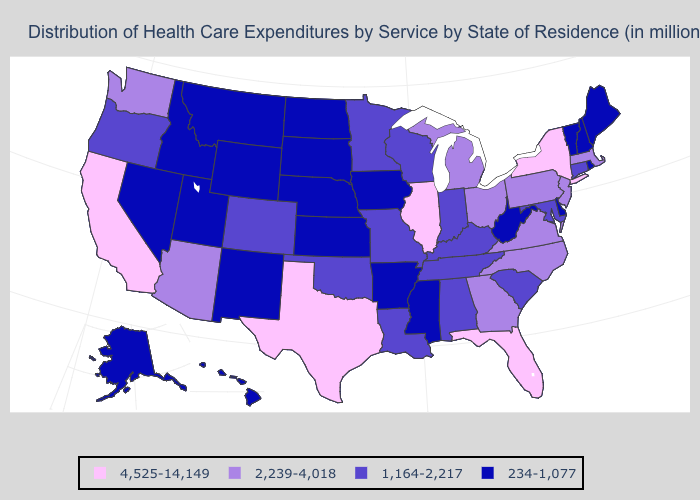Name the states that have a value in the range 234-1,077?
Concise answer only. Alaska, Arkansas, Delaware, Hawaii, Idaho, Iowa, Kansas, Maine, Mississippi, Montana, Nebraska, Nevada, New Hampshire, New Mexico, North Dakota, Rhode Island, South Dakota, Utah, Vermont, West Virginia, Wyoming. Which states have the highest value in the USA?
Write a very short answer. California, Florida, Illinois, New York, Texas. What is the value of Hawaii?
Be succinct. 234-1,077. What is the value of Nebraska?
Write a very short answer. 234-1,077. What is the lowest value in states that border Colorado?
Concise answer only. 234-1,077. Does Minnesota have the lowest value in the USA?
Keep it brief. No. What is the value of New Hampshire?
Keep it brief. 234-1,077. How many symbols are there in the legend?
Keep it brief. 4. What is the highest value in states that border Michigan?
Keep it brief. 2,239-4,018. Name the states that have a value in the range 1,164-2,217?
Answer briefly. Alabama, Colorado, Connecticut, Indiana, Kentucky, Louisiana, Maryland, Minnesota, Missouri, Oklahoma, Oregon, South Carolina, Tennessee, Wisconsin. Among the states that border Alabama , which have the highest value?
Concise answer only. Florida. Which states have the lowest value in the West?
Quick response, please. Alaska, Hawaii, Idaho, Montana, Nevada, New Mexico, Utah, Wyoming. What is the lowest value in the USA?
Be succinct. 234-1,077. Does the map have missing data?
Be succinct. No. Name the states that have a value in the range 2,239-4,018?
Keep it brief. Arizona, Georgia, Massachusetts, Michigan, New Jersey, North Carolina, Ohio, Pennsylvania, Virginia, Washington. 